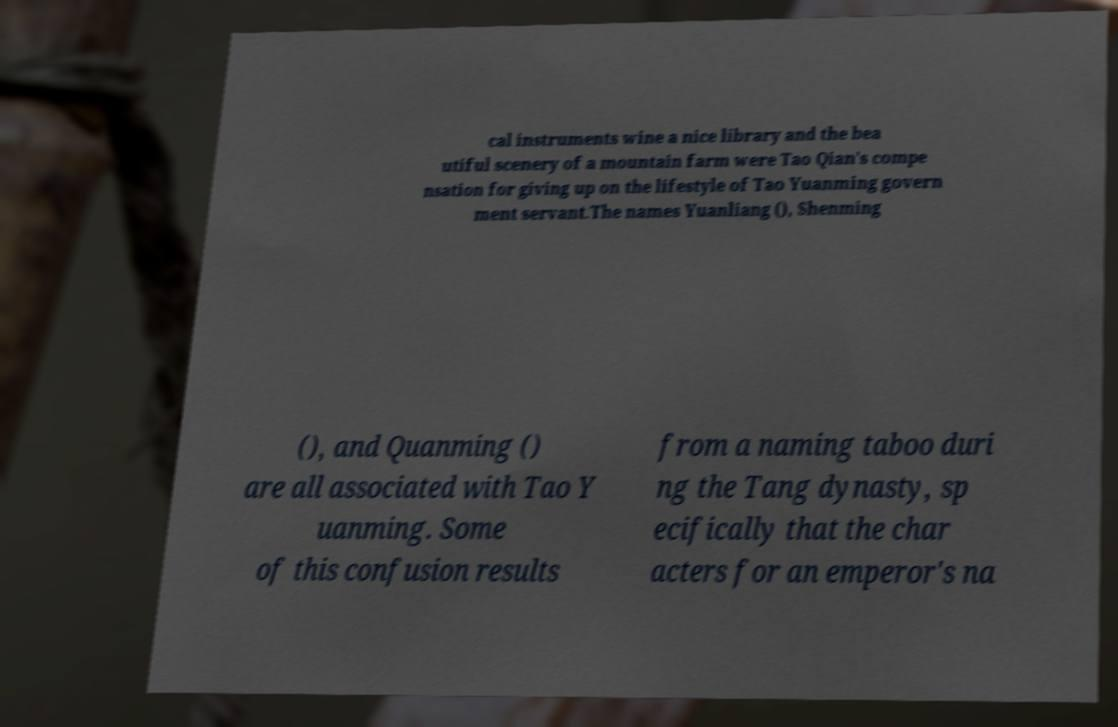Can you read and provide the text displayed in the image?This photo seems to have some interesting text. Can you extract and type it out for me? cal instruments wine a nice library and the bea utiful scenery of a mountain farm were Tao Qian's compe nsation for giving up on the lifestyle of Tao Yuanming govern ment servant.The names Yuanliang (), Shenming (), and Quanming () are all associated with Tao Y uanming. Some of this confusion results from a naming taboo duri ng the Tang dynasty, sp ecifically that the char acters for an emperor's na 